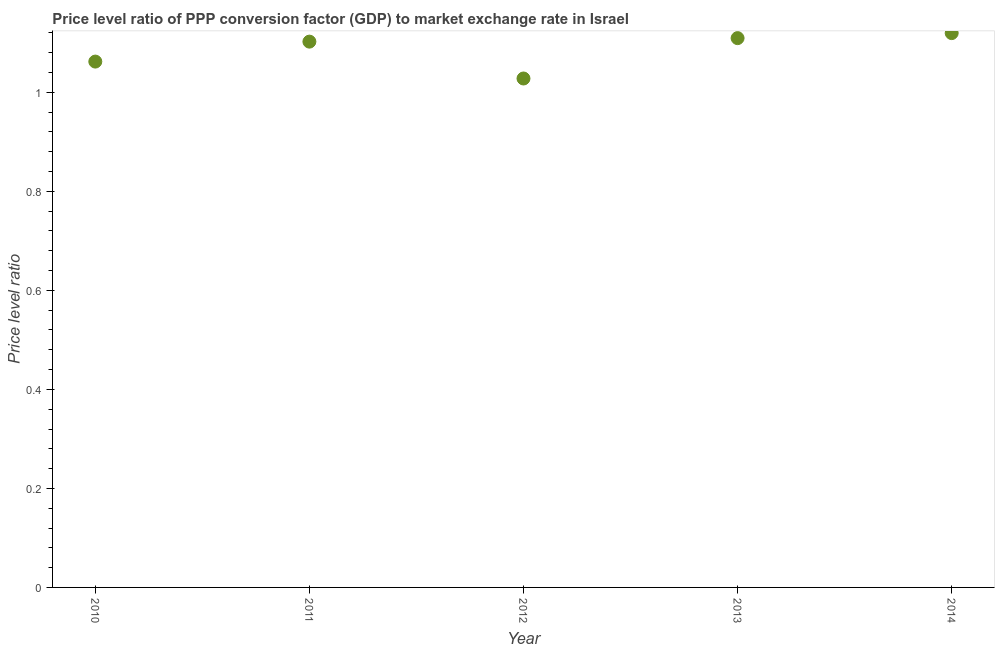What is the price level ratio in 2014?
Keep it short and to the point. 1.12. Across all years, what is the maximum price level ratio?
Your answer should be compact. 1.12. Across all years, what is the minimum price level ratio?
Your answer should be very brief. 1.03. What is the sum of the price level ratio?
Your response must be concise. 5.42. What is the difference between the price level ratio in 2010 and 2014?
Provide a short and direct response. -0.06. What is the average price level ratio per year?
Provide a succinct answer. 1.08. What is the median price level ratio?
Offer a terse response. 1.1. In how many years, is the price level ratio greater than 0.6400000000000001 ?
Give a very brief answer. 5. Do a majority of the years between 2011 and 2013 (inclusive) have price level ratio greater than 0.48000000000000004 ?
Make the answer very short. Yes. What is the ratio of the price level ratio in 2011 to that in 2014?
Your response must be concise. 0.98. Is the price level ratio in 2010 less than that in 2013?
Keep it short and to the point. Yes. What is the difference between the highest and the second highest price level ratio?
Your answer should be very brief. 0.01. Is the sum of the price level ratio in 2010 and 2014 greater than the maximum price level ratio across all years?
Offer a very short reply. Yes. What is the difference between the highest and the lowest price level ratio?
Provide a short and direct response. 0.09. In how many years, is the price level ratio greater than the average price level ratio taken over all years?
Provide a short and direct response. 3. How many dotlines are there?
Provide a succinct answer. 1. How many years are there in the graph?
Ensure brevity in your answer.  5. What is the difference between two consecutive major ticks on the Y-axis?
Your answer should be very brief. 0.2. Are the values on the major ticks of Y-axis written in scientific E-notation?
Provide a short and direct response. No. Does the graph contain any zero values?
Your answer should be compact. No. Does the graph contain grids?
Offer a terse response. No. What is the title of the graph?
Your answer should be compact. Price level ratio of PPP conversion factor (GDP) to market exchange rate in Israel. What is the label or title of the X-axis?
Your answer should be very brief. Year. What is the label or title of the Y-axis?
Offer a very short reply. Price level ratio. What is the Price level ratio in 2010?
Your answer should be compact. 1.06. What is the Price level ratio in 2011?
Your answer should be compact. 1.1. What is the Price level ratio in 2012?
Your response must be concise. 1.03. What is the Price level ratio in 2013?
Your response must be concise. 1.11. What is the Price level ratio in 2014?
Ensure brevity in your answer.  1.12. What is the difference between the Price level ratio in 2010 and 2011?
Your answer should be very brief. -0.04. What is the difference between the Price level ratio in 2010 and 2012?
Ensure brevity in your answer.  0.03. What is the difference between the Price level ratio in 2010 and 2013?
Ensure brevity in your answer.  -0.05. What is the difference between the Price level ratio in 2010 and 2014?
Provide a short and direct response. -0.06. What is the difference between the Price level ratio in 2011 and 2012?
Give a very brief answer. 0.07. What is the difference between the Price level ratio in 2011 and 2013?
Your answer should be compact. -0.01. What is the difference between the Price level ratio in 2011 and 2014?
Offer a very short reply. -0.02. What is the difference between the Price level ratio in 2012 and 2013?
Your response must be concise. -0.08. What is the difference between the Price level ratio in 2012 and 2014?
Provide a short and direct response. -0.09. What is the difference between the Price level ratio in 2013 and 2014?
Provide a succinct answer. -0.01. What is the ratio of the Price level ratio in 2010 to that in 2011?
Your answer should be very brief. 0.96. What is the ratio of the Price level ratio in 2010 to that in 2012?
Provide a succinct answer. 1.03. What is the ratio of the Price level ratio in 2010 to that in 2013?
Keep it short and to the point. 0.96. What is the ratio of the Price level ratio in 2010 to that in 2014?
Your response must be concise. 0.95. What is the ratio of the Price level ratio in 2011 to that in 2012?
Make the answer very short. 1.07. What is the ratio of the Price level ratio in 2011 to that in 2013?
Offer a terse response. 0.99. What is the ratio of the Price level ratio in 2011 to that in 2014?
Provide a short and direct response. 0.98. What is the ratio of the Price level ratio in 2012 to that in 2013?
Make the answer very short. 0.93. What is the ratio of the Price level ratio in 2012 to that in 2014?
Give a very brief answer. 0.92. 